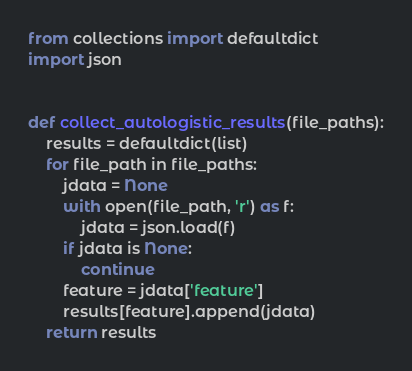Convert code to text. <code><loc_0><loc_0><loc_500><loc_500><_Python_>from collections import defaultdict
import json


def collect_autologistic_results(file_paths):
    results = defaultdict(list)
    for file_path in file_paths:
        jdata = None
        with open(file_path, 'r') as f:
            jdata = json.load(f)
        if jdata is None:
            continue
        feature = jdata['feature']
        results[feature].append(jdata)
    return results
</code> 